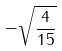<formula> <loc_0><loc_0><loc_500><loc_500>- \sqrt { \frac { 4 } { 1 5 } }</formula> 